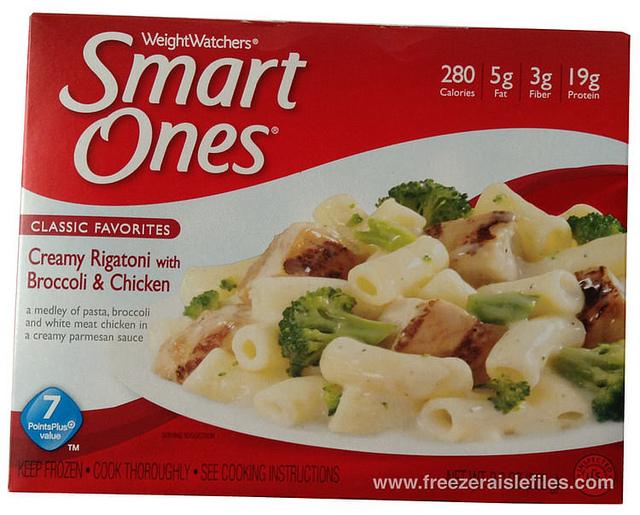How many calories are in this meal?
Quick response, please. 280. Is this item likely to be high in sodium?
Answer briefly. Yes. Is the food cooked?
Quick response, please. No. 